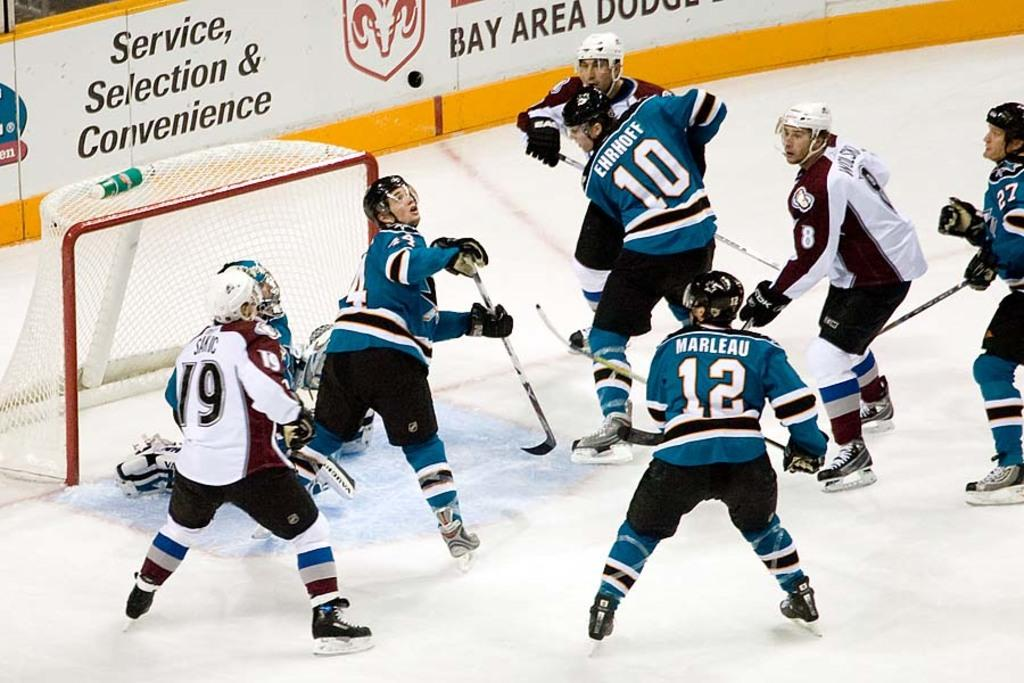<image>
Write a terse but informative summary of the picture. Hockey players scramble after the puck on a rink which is partially sponsored by a Bay area Dodge dealership. 